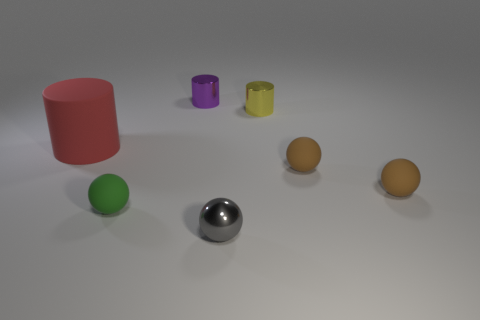Is the shape of the small green matte object the same as the small gray thing?
Keep it short and to the point. Yes. How big is the shiny cylinder that is in front of the tiny cylinder on the left side of the tiny metal object that is in front of the rubber cylinder?
Give a very brief answer. Small. There is a small purple object that is the same shape as the tiny yellow object; what material is it?
Your answer should be very brief. Metal. Is there anything else that is the same size as the red matte thing?
Provide a succinct answer. No. How big is the metallic thing that is in front of the tiny matte ball to the left of the yellow thing?
Keep it short and to the point. Small. What is the color of the big rubber object?
Give a very brief answer. Red. How many small things are left of the shiny object that is in front of the large rubber cylinder?
Provide a short and direct response. 2. Is there a small yellow cylinder to the left of the tiny matte sphere that is left of the gray thing?
Keep it short and to the point. No. There is a gray thing; are there any small matte spheres on the right side of it?
Offer a terse response. Yes. Is the shape of the tiny metallic thing in front of the yellow thing the same as  the green matte thing?
Your answer should be compact. Yes. 